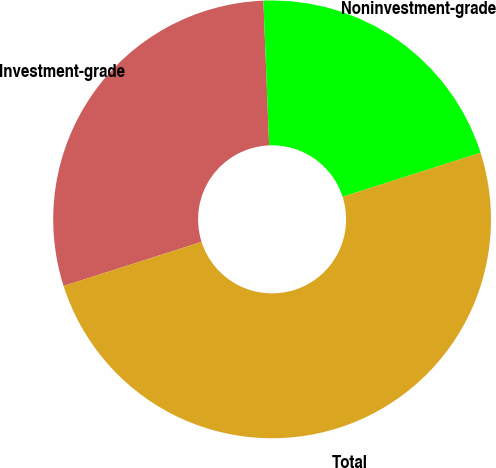<chart> <loc_0><loc_0><loc_500><loc_500><pie_chart><fcel>Investment-grade<fcel>Noninvestment-grade<fcel>Total<nl><fcel>29.29%<fcel>20.71%<fcel>50.0%<nl></chart> 